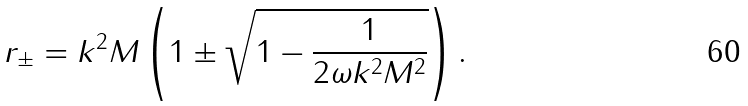<formula> <loc_0><loc_0><loc_500><loc_500>r _ { \pm } = k ^ { 2 } M \left ( 1 \pm \sqrt { 1 - \frac { 1 } { 2 \omega k ^ { 2 } M ^ { 2 } } } \right ) .</formula> 